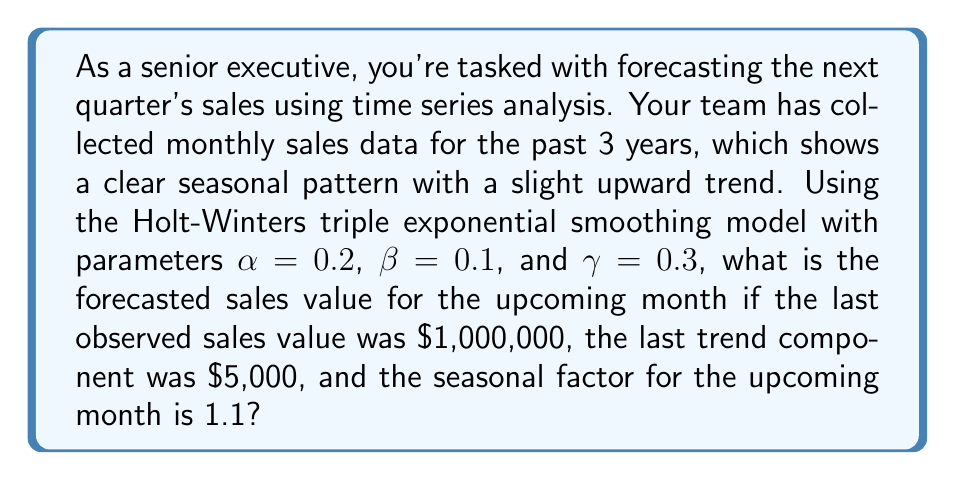Provide a solution to this math problem. Let's approach this step-by-step using the Holt-Winters triple exponential smoothing model:

1) The Holt-Winters model has three components: level (L), trend (T), and seasonal (S). The forecast is calculated as:

   $F_{t+1} = (L_t + T_t) \cdot S_{t+1}$

2) We need to update each component using the given parameters:
   $\alpha = 0.2$ (level smoothing)
   $\beta = 0.1$ (trend smoothing)
   $\gamma = 0.3$ (seasonal smoothing)

3) Update the level component:
   $L_t = \alpha \cdot \frac{Y_t}{S_t} + (1-\alpha)(L_{t-1} + T_{t-1})$
   $L_t = 0.2 \cdot \frac{1,000,000}{1.1} + 0.8(1,000,000 + 5,000)$
   $L_t = 181,818.18 + 804,000 = 985,818.18$

4) Update the trend component:
   $T_t = \beta \cdot (L_t - L_{t-1}) + (1-\beta)T_{t-1}$
   $T_t = 0.1 \cdot (985,818.18 - 1,000,000) + 0.9 \cdot 5,000$
   $T_t = -1,418.18 + 4,500 = 3,081.82$

5) The seasonal component for the upcoming month is given as 1.1

6) Now we can calculate the forecast:
   $F_{t+1} = (L_t + T_t) \cdot S_{t+1}$
   $F_{t+1} = (985,818.18 + 3,081.82) \cdot 1.1$
   $F_{t+1} = 988,900 \cdot 1.1 = 1,087,790$

Therefore, the forecasted sales value for the upcoming month is $1,087,790.
Answer: $1,087,790 